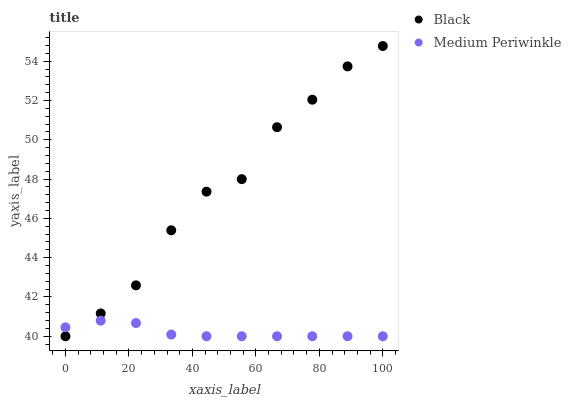Does Medium Periwinkle have the minimum area under the curve?
Answer yes or no. Yes. Does Black have the maximum area under the curve?
Answer yes or no. Yes. Does Black have the minimum area under the curve?
Answer yes or no. No. Is Medium Periwinkle the smoothest?
Answer yes or no. Yes. Is Black the roughest?
Answer yes or no. Yes. Is Black the smoothest?
Answer yes or no. No. Does Medium Periwinkle have the lowest value?
Answer yes or no. Yes. Does Black have the highest value?
Answer yes or no. Yes. Does Medium Periwinkle intersect Black?
Answer yes or no. Yes. Is Medium Periwinkle less than Black?
Answer yes or no. No. Is Medium Periwinkle greater than Black?
Answer yes or no. No. 